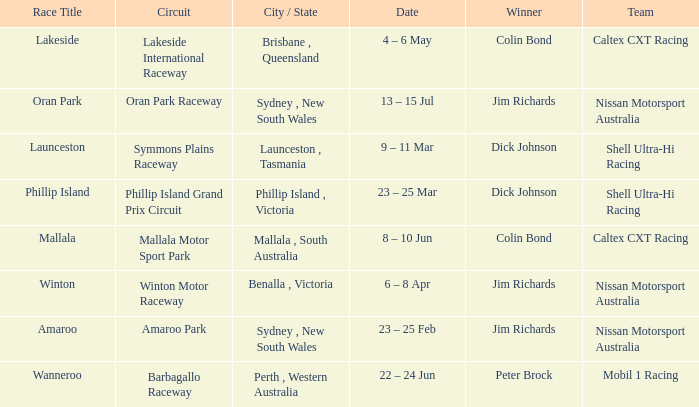Name the team for launceston Shell Ultra-Hi Racing. 